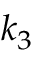Convert formula to latex. <formula><loc_0><loc_0><loc_500><loc_500>k _ { 3 }</formula> 